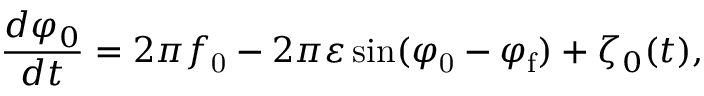<formula> <loc_0><loc_0><loc_500><loc_500>\frac { d \varphi _ { 0 } } { d t } = 2 \pi f _ { 0 } - 2 \pi \varepsilon \sin ( \varphi _ { 0 } - \varphi _ { f } ) + \zeta _ { 0 } ( t ) ,</formula> 